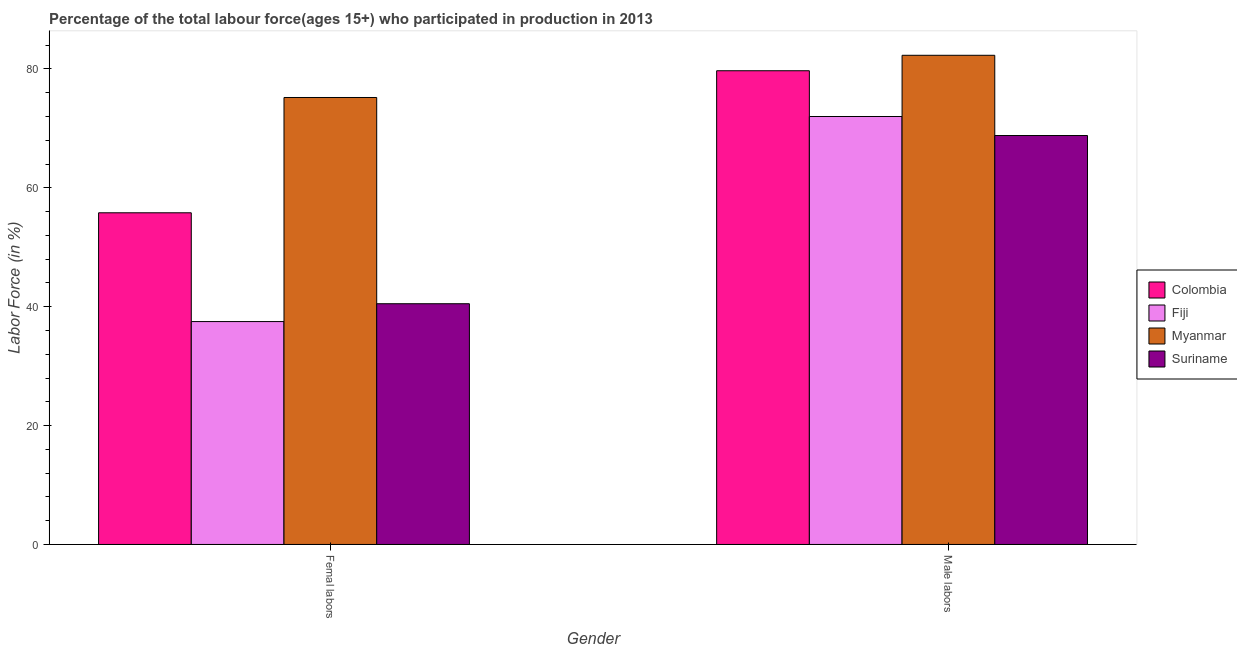What is the label of the 2nd group of bars from the left?
Give a very brief answer. Male labors. What is the percentage of female labor force in Colombia?
Ensure brevity in your answer.  55.8. Across all countries, what is the maximum percentage of male labour force?
Make the answer very short. 82.3. Across all countries, what is the minimum percentage of male labour force?
Keep it short and to the point. 68.8. In which country was the percentage of male labour force maximum?
Give a very brief answer. Myanmar. In which country was the percentage of male labour force minimum?
Your answer should be compact. Suriname. What is the total percentage of female labor force in the graph?
Provide a succinct answer. 209. What is the difference between the percentage of male labour force in Colombia and that in Fiji?
Make the answer very short. 7.7. What is the difference between the percentage of male labour force in Myanmar and the percentage of female labor force in Colombia?
Make the answer very short. 26.5. What is the average percentage of female labor force per country?
Ensure brevity in your answer.  52.25. What is the difference between the percentage of female labor force and percentage of male labour force in Suriname?
Your answer should be very brief. -28.3. What is the ratio of the percentage of male labour force in Suriname to that in Colombia?
Give a very brief answer. 0.86. In how many countries, is the percentage of female labor force greater than the average percentage of female labor force taken over all countries?
Offer a very short reply. 2. What does the 3rd bar from the left in Male labors represents?
Keep it short and to the point. Myanmar. Are all the bars in the graph horizontal?
Keep it short and to the point. No. Does the graph contain any zero values?
Your answer should be very brief. No. Where does the legend appear in the graph?
Give a very brief answer. Center right. How are the legend labels stacked?
Provide a succinct answer. Vertical. What is the title of the graph?
Offer a very short reply. Percentage of the total labour force(ages 15+) who participated in production in 2013. Does "Sierra Leone" appear as one of the legend labels in the graph?
Your response must be concise. No. What is the label or title of the X-axis?
Provide a short and direct response. Gender. What is the Labor Force (in %) of Colombia in Femal labors?
Offer a very short reply. 55.8. What is the Labor Force (in %) of Fiji in Femal labors?
Give a very brief answer. 37.5. What is the Labor Force (in %) in Myanmar in Femal labors?
Your answer should be very brief. 75.2. What is the Labor Force (in %) of Suriname in Femal labors?
Make the answer very short. 40.5. What is the Labor Force (in %) of Colombia in Male labors?
Your response must be concise. 79.7. What is the Labor Force (in %) in Myanmar in Male labors?
Keep it short and to the point. 82.3. What is the Labor Force (in %) in Suriname in Male labors?
Provide a short and direct response. 68.8. Across all Gender, what is the maximum Labor Force (in %) of Colombia?
Provide a succinct answer. 79.7. Across all Gender, what is the maximum Labor Force (in %) of Fiji?
Make the answer very short. 72. Across all Gender, what is the maximum Labor Force (in %) of Myanmar?
Your answer should be compact. 82.3. Across all Gender, what is the maximum Labor Force (in %) in Suriname?
Offer a terse response. 68.8. Across all Gender, what is the minimum Labor Force (in %) in Colombia?
Provide a short and direct response. 55.8. Across all Gender, what is the minimum Labor Force (in %) of Fiji?
Ensure brevity in your answer.  37.5. Across all Gender, what is the minimum Labor Force (in %) in Myanmar?
Your response must be concise. 75.2. Across all Gender, what is the minimum Labor Force (in %) of Suriname?
Make the answer very short. 40.5. What is the total Labor Force (in %) of Colombia in the graph?
Provide a short and direct response. 135.5. What is the total Labor Force (in %) in Fiji in the graph?
Your response must be concise. 109.5. What is the total Labor Force (in %) in Myanmar in the graph?
Your answer should be compact. 157.5. What is the total Labor Force (in %) in Suriname in the graph?
Offer a very short reply. 109.3. What is the difference between the Labor Force (in %) in Colombia in Femal labors and that in Male labors?
Ensure brevity in your answer.  -23.9. What is the difference between the Labor Force (in %) in Fiji in Femal labors and that in Male labors?
Your answer should be compact. -34.5. What is the difference between the Labor Force (in %) in Myanmar in Femal labors and that in Male labors?
Make the answer very short. -7.1. What is the difference between the Labor Force (in %) in Suriname in Femal labors and that in Male labors?
Offer a terse response. -28.3. What is the difference between the Labor Force (in %) of Colombia in Femal labors and the Labor Force (in %) of Fiji in Male labors?
Provide a succinct answer. -16.2. What is the difference between the Labor Force (in %) of Colombia in Femal labors and the Labor Force (in %) of Myanmar in Male labors?
Provide a succinct answer. -26.5. What is the difference between the Labor Force (in %) of Colombia in Femal labors and the Labor Force (in %) of Suriname in Male labors?
Your response must be concise. -13. What is the difference between the Labor Force (in %) in Fiji in Femal labors and the Labor Force (in %) in Myanmar in Male labors?
Give a very brief answer. -44.8. What is the difference between the Labor Force (in %) in Fiji in Femal labors and the Labor Force (in %) in Suriname in Male labors?
Ensure brevity in your answer.  -31.3. What is the difference between the Labor Force (in %) in Myanmar in Femal labors and the Labor Force (in %) in Suriname in Male labors?
Make the answer very short. 6.4. What is the average Labor Force (in %) of Colombia per Gender?
Your answer should be very brief. 67.75. What is the average Labor Force (in %) in Fiji per Gender?
Give a very brief answer. 54.75. What is the average Labor Force (in %) in Myanmar per Gender?
Your answer should be very brief. 78.75. What is the average Labor Force (in %) in Suriname per Gender?
Your answer should be compact. 54.65. What is the difference between the Labor Force (in %) in Colombia and Labor Force (in %) in Myanmar in Femal labors?
Provide a short and direct response. -19.4. What is the difference between the Labor Force (in %) in Fiji and Labor Force (in %) in Myanmar in Femal labors?
Your answer should be compact. -37.7. What is the difference between the Labor Force (in %) in Fiji and Labor Force (in %) in Suriname in Femal labors?
Provide a succinct answer. -3. What is the difference between the Labor Force (in %) in Myanmar and Labor Force (in %) in Suriname in Femal labors?
Give a very brief answer. 34.7. What is the difference between the Labor Force (in %) of Colombia and Labor Force (in %) of Fiji in Male labors?
Give a very brief answer. 7.7. What is the difference between the Labor Force (in %) of Colombia and Labor Force (in %) of Suriname in Male labors?
Your answer should be very brief. 10.9. What is the difference between the Labor Force (in %) in Fiji and Labor Force (in %) in Myanmar in Male labors?
Ensure brevity in your answer.  -10.3. What is the difference between the Labor Force (in %) in Myanmar and Labor Force (in %) in Suriname in Male labors?
Offer a very short reply. 13.5. What is the ratio of the Labor Force (in %) of Colombia in Femal labors to that in Male labors?
Make the answer very short. 0.7. What is the ratio of the Labor Force (in %) of Fiji in Femal labors to that in Male labors?
Keep it short and to the point. 0.52. What is the ratio of the Labor Force (in %) in Myanmar in Femal labors to that in Male labors?
Give a very brief answer. 0.91. What is the ratio of the Labor Force (in %) of Suriname in Femal labors to that in Male labors?
Give a very brief answer. 0.59. What is the difference between the highest and the second highest Labor Force (in %) of Colombia?
Your response must be concise. 23.9. What is the difference between the highest and the second highest Labor Force (in %) of Fiji?
Offer a very short reply. 34.5. What is the difference between the highest and the second highest Labor Force (in %) in Suriname?
Keep it short and to the point. 28.3. What is the difference between the highest and the lowest Labor Force (in %) in Colombia?
Offer a very short reply. 23.9. What is the difference between the highest and the lowest Labor Force (in %) of Fiji?
Keep it short and to the point. 34.5. What is the difference between the highest and the lowest Labor Force (in %) of Suriname?
Your answer should be compact. 28.3. 